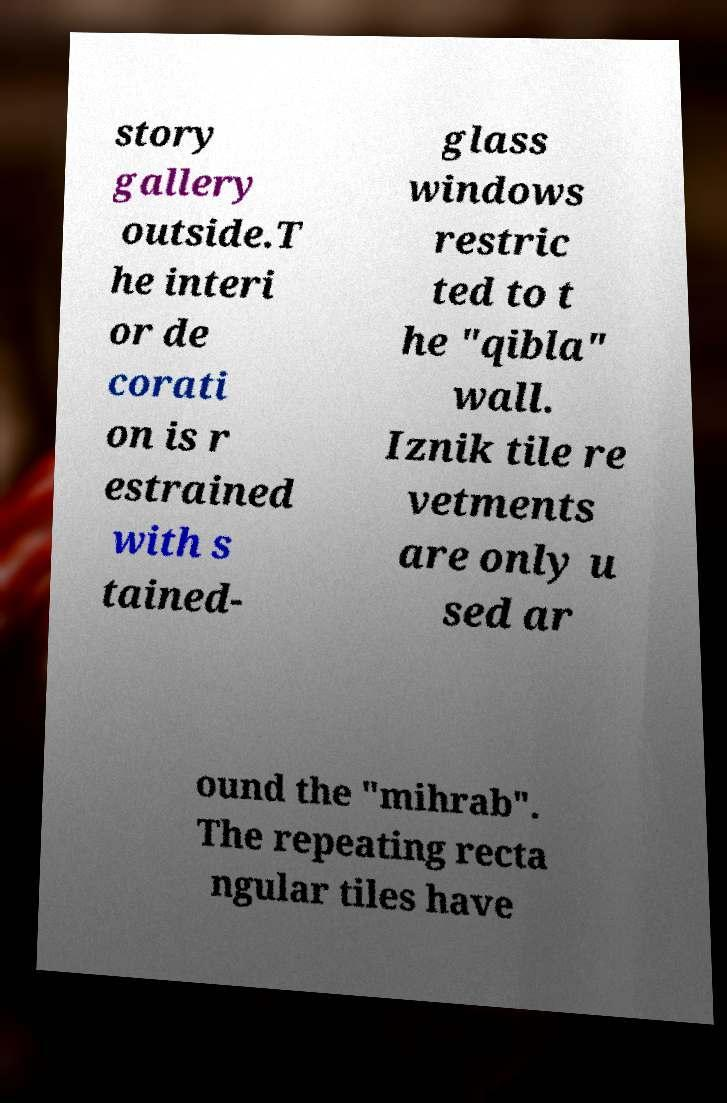What messages or text are displayed in this image? I need them in a readable, typed format. story gallery outside.T he interi or de corati on is r estrained with s tained- glass windows restric ted to t he "qibla" wall. Iznik tile re vetments are only u sed ar ound the "mihrab". The repeating recta ngular tiles have 